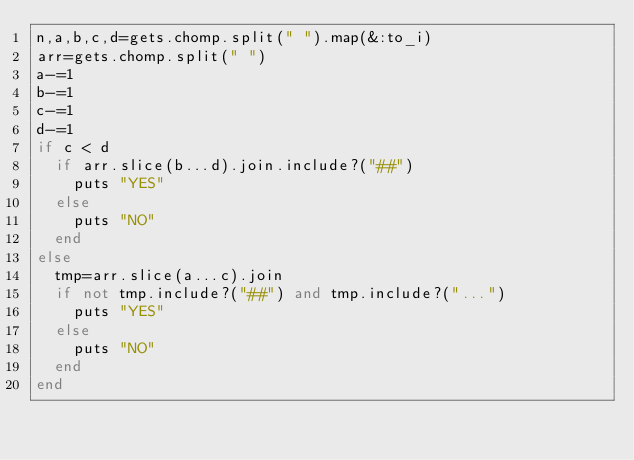Convert code to text. <code><loc_0><loc_0><loc_500><loc_500><_Ruby_>n,a,b,c,d=gets.chomp.split(" ").map(&:to_i)
arr=gets.chomp.split(" ")
a-=1
b-=1
c-=1
d-=1
if c < d
  if arr.slice(b...d).join.include?("##")
    puts "YES"
  else
    puts "NO"
  end
else
  tmp=arr.slice(a...c).join
  if not tmp.include?("##") and tmp.include?("...")
    puts "YES"
  else
    puts "NO"
  end
end
    </code> 